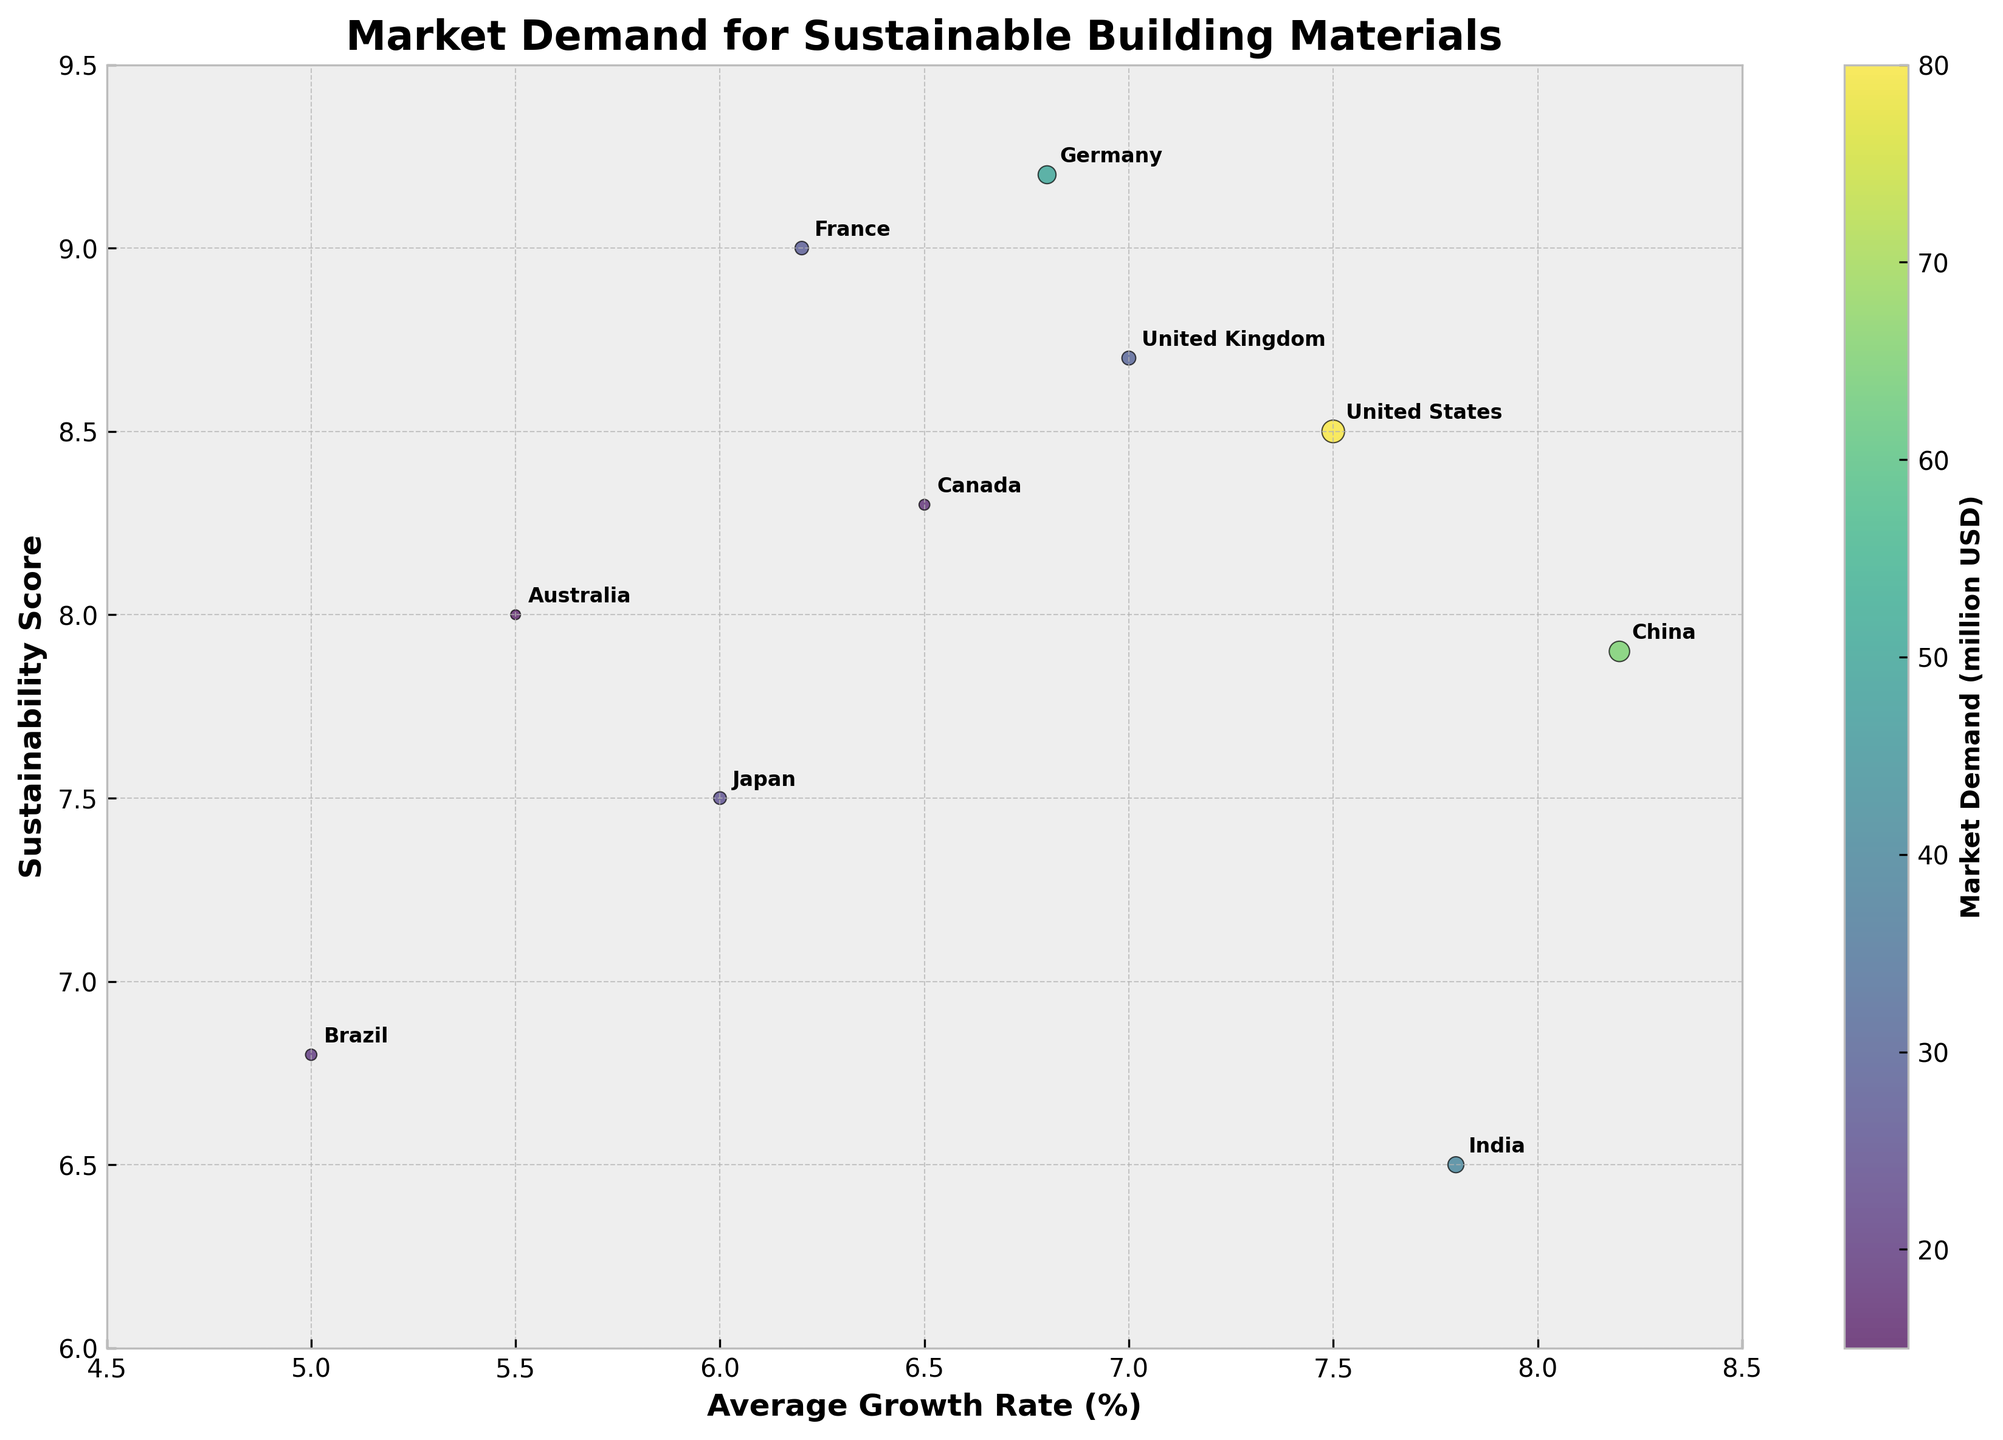What's the title of the chart? The title of the chart is located at the top and describes the main content of the figure.
Answer: Market Demand for Sustainable Building Materials Which country has the highest sustainability score? To identify the country with the highest score, look at the y-axis and find the highest point on the scatterplot, then check the labeled country.
Answer: Germany What is the average growth rate of building materials in the United States? Find the bubble labeled "United States" and check its x-axis value for the average growth rate.
Answer: 7.5% How does France's sustainability score compare to that of Canada? Locate both France and Canada on the scatterplot and compare their positions on the y-axis, which represents the sustainability score.
Answer: France has a higher sustainability score (9.0) compared to Canada (8.3) Which country has the smallest market demand for sustainable building materials? Identify the smallest bubble on the scatterplot and note the labeled country.
Answer: Australia Compare the market demand between China and Brazil. Which country has a higher demand? Locate both China and Brazil on the plot and compare the sizes of their bubbles. The larger bubble indicates higher market demand.
Answer: China What's the combined market demand for Germany and Japan? Add the market demand values for both Germany and Japan. Germany = 500 million USD, Japan = 250 million USD.
Answer: 750 million USD Describe the relationship between average growth rate and sustainability score for the United Kingdom. Find the bubble labeled "United Kingdom" and check its position on the x-axis for growth rate and the y-axis for sustainability score.
Answer: The United Kingdom has an average growth rate of 7.0% and a sustainability score of 8.7 Which country has the highest average growth rate, and what is its sustainability score? Identify the bubble farthest to the right on the x-axis, then check the label and the sustainability score on the y-axis.
Answer: China, with a sustainability score of 7.9 Is there a country with a sustainability score of exactly 7.5? If yes, which one? Look at the y-axis for the value 7.5 and see if there is a bubble intersecting that point.
Answer: Yes, Japan 